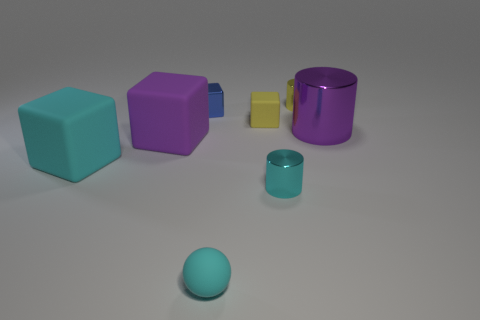Subtract all big cylinders. How many cylinders are left? 2 Subtract 1 cubes. How many cubes are left? 3 Add 1 blue objects. How many objects exist? 9 Subtract all red blocks. Subtract all purple cylinders. How many blocks are left? 4 Subtract all balls. How many objects are left? 7 Subtract all matte blocks. Subtract all large purple matte cubes. How many objects are left? 4 Add 1 purple cylinders. How many purple cylinders are left? 2 Add 1 yellow rubber things. How many yellow rubber things exist? 2 Subtract 1 cyan cylinders. How many objects are left? 7 